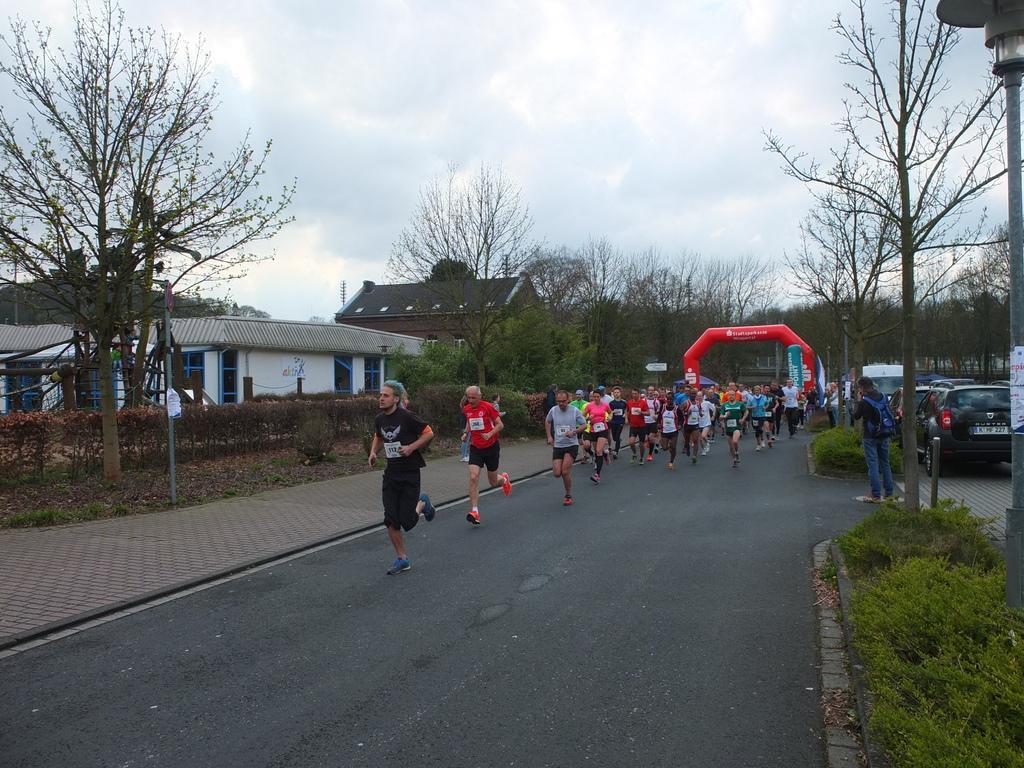Describe this image in one or two sentences. In this picture I can see few people running on the road and I can see few cars and vehicles parked. I can see buildings, few people standing and I can see plants and a inflatable arch in the back. I can see few trees and a cloudy sky. 